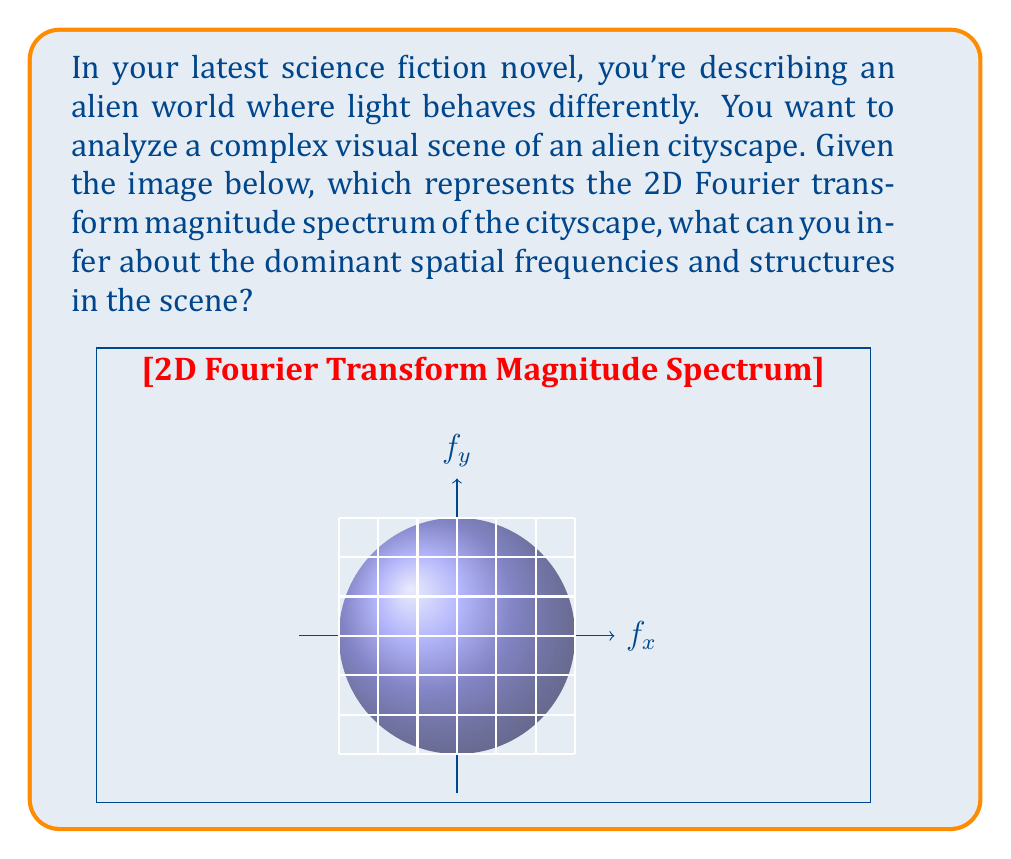Can you answer this question? To analyze this 2D Fourier transform magnitude spectrum, we need to understand that:

1) The origin (center of the image) represents the DC component (average brightness).

2) Distance from the origin corresponds to spatial frequency - points further from the center represent higher frequencies.

3) The brightness of each point indicates the magnitude of that frequency component.

4) The angle from the horizontal axis represents the orientation of spatial frequencies.

Analyzing the image:

1) The bright center indicates a strong DC component, suggesting overall brightness in the original image.

2) We see a bright, circular region around the center, indicating significant low-frequency content. This suggests large-scale structures or gradual changes in the cityscape.

3) There are distinct bright spots along the $f_x$ and $f_y$ axes, symmetrically placed around the origin. This indicates:
   a) Along $f_x$: Regular vertical structures in the cityscape, like tall buildings or columns.
   b) Along $f_y$: Regular horizontal structures, possibly like layers or levels in the buildings.

4) The bright spots along $f_x$ are closer to the origin than those along $f_y$, suggesting that the vertical structures are wider (lower frequency) than the horizontal structures.

5) The overall circular symmetry suggests that the cityscape has no strong directional bias in its layout.

6) The gradual fading of brightness towards the edges indicates a smooth falloff of high-frequency components, suggesting the absence of very fine details or sharp edges in the original image.

The Fourier transform is given by:

$$ F(f_x, f_y) = \int_{-\infty}^{\infty} \int_{-\infty}^{\infty} f(x,y) e^{-2\pi i(f_x x + f_y y)} dx dy $$

Where $f(x,y)$ is the original image and $F(f_x, f_y)$ is its Fourier transform.
Answer: The cityscape likely features large-scale structures with regular vertical (wider) and horizontal (narrower) elements, smooth transitions, and a lack of very fine details. 